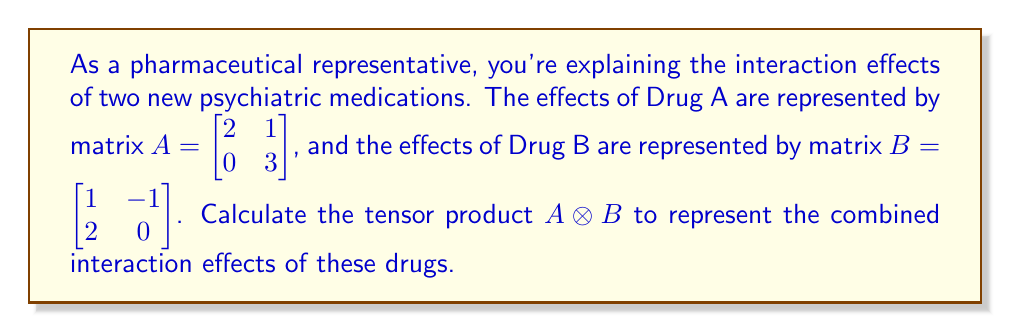Can you solve this math problem? To find the tensor product of two matrices, we follow these steps:

1) The tensor product $A \otimes B$ is defined as:

   $$A \otimes B = \begin{bmatrix} 
   a_{11}B & a_{12}B \\
   a_{21}B & a_{22}B
   \end{bmatrix}$$

2) Let's calculate each component:

   $a_{11}B = 2 \begin{bmatrix} 1 & -1 \\ 2 & 0 \end{bmatrix} = \begin{bmatrix} 2 & -2 \\ 4 & 0 \end{bmatrix}$

   $a_{12}B = 1 \begin{bmatrix} 1 & -1 \\ 2 & 0 \end{bmatrix} = \begin{bmatrix} 1 & -1 \\ 2 & 0 \end{bmatrix}$

   $a_{21}B = 0 \begin{bmatrix} 1 & -1 \\ 2 & 0 \end{bmatrix} = \begin{bmatrix} 0 & 0 \\ 0 & 0 \end{bmatrix}$

   $a_{22}B = 3 \begin{bmatrix} 1 & -1 \\ 2 & 0 \end{bmatrix} = \begin{bmatrix} 3 & -3 \\ 6 & 0 \end{bmatrix}$

3) Now, we arrange these in the 4x4 matrix:

   $$A \otimes B = \begin{bmatrix} 
   2 & -2 & 1 & -1 \\
   4 & 0 & 2 & 0 \\
   0 & 0 & 3 & -3 \\
   0 & 0 & 6 & 0
   \end{bmatrix}$$

This resulting matrix represents the combined interaction effects of Drug A and Drug B.
Answer: $$\begin{bmatrix} 
2 & -2 & 1 & -1 \\
4 & 0 & 2 & 0 \\
0 & 0 & 3 & -3 \\
0 & 0 & 6 & 0
\end{bmatrix}$$ 